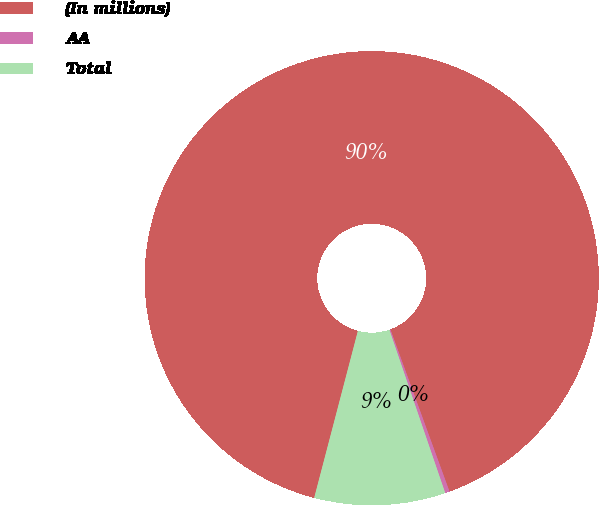Convert chart to OTSL. <chart><loc_0><loc_0><loc_500><loc_500><pie_chart><fcel>(In millions)<fcel>AA<fcel>Total<nl><fcel>90.36%<fcel>0.32%<fcel>9.32%<nl></chart> 